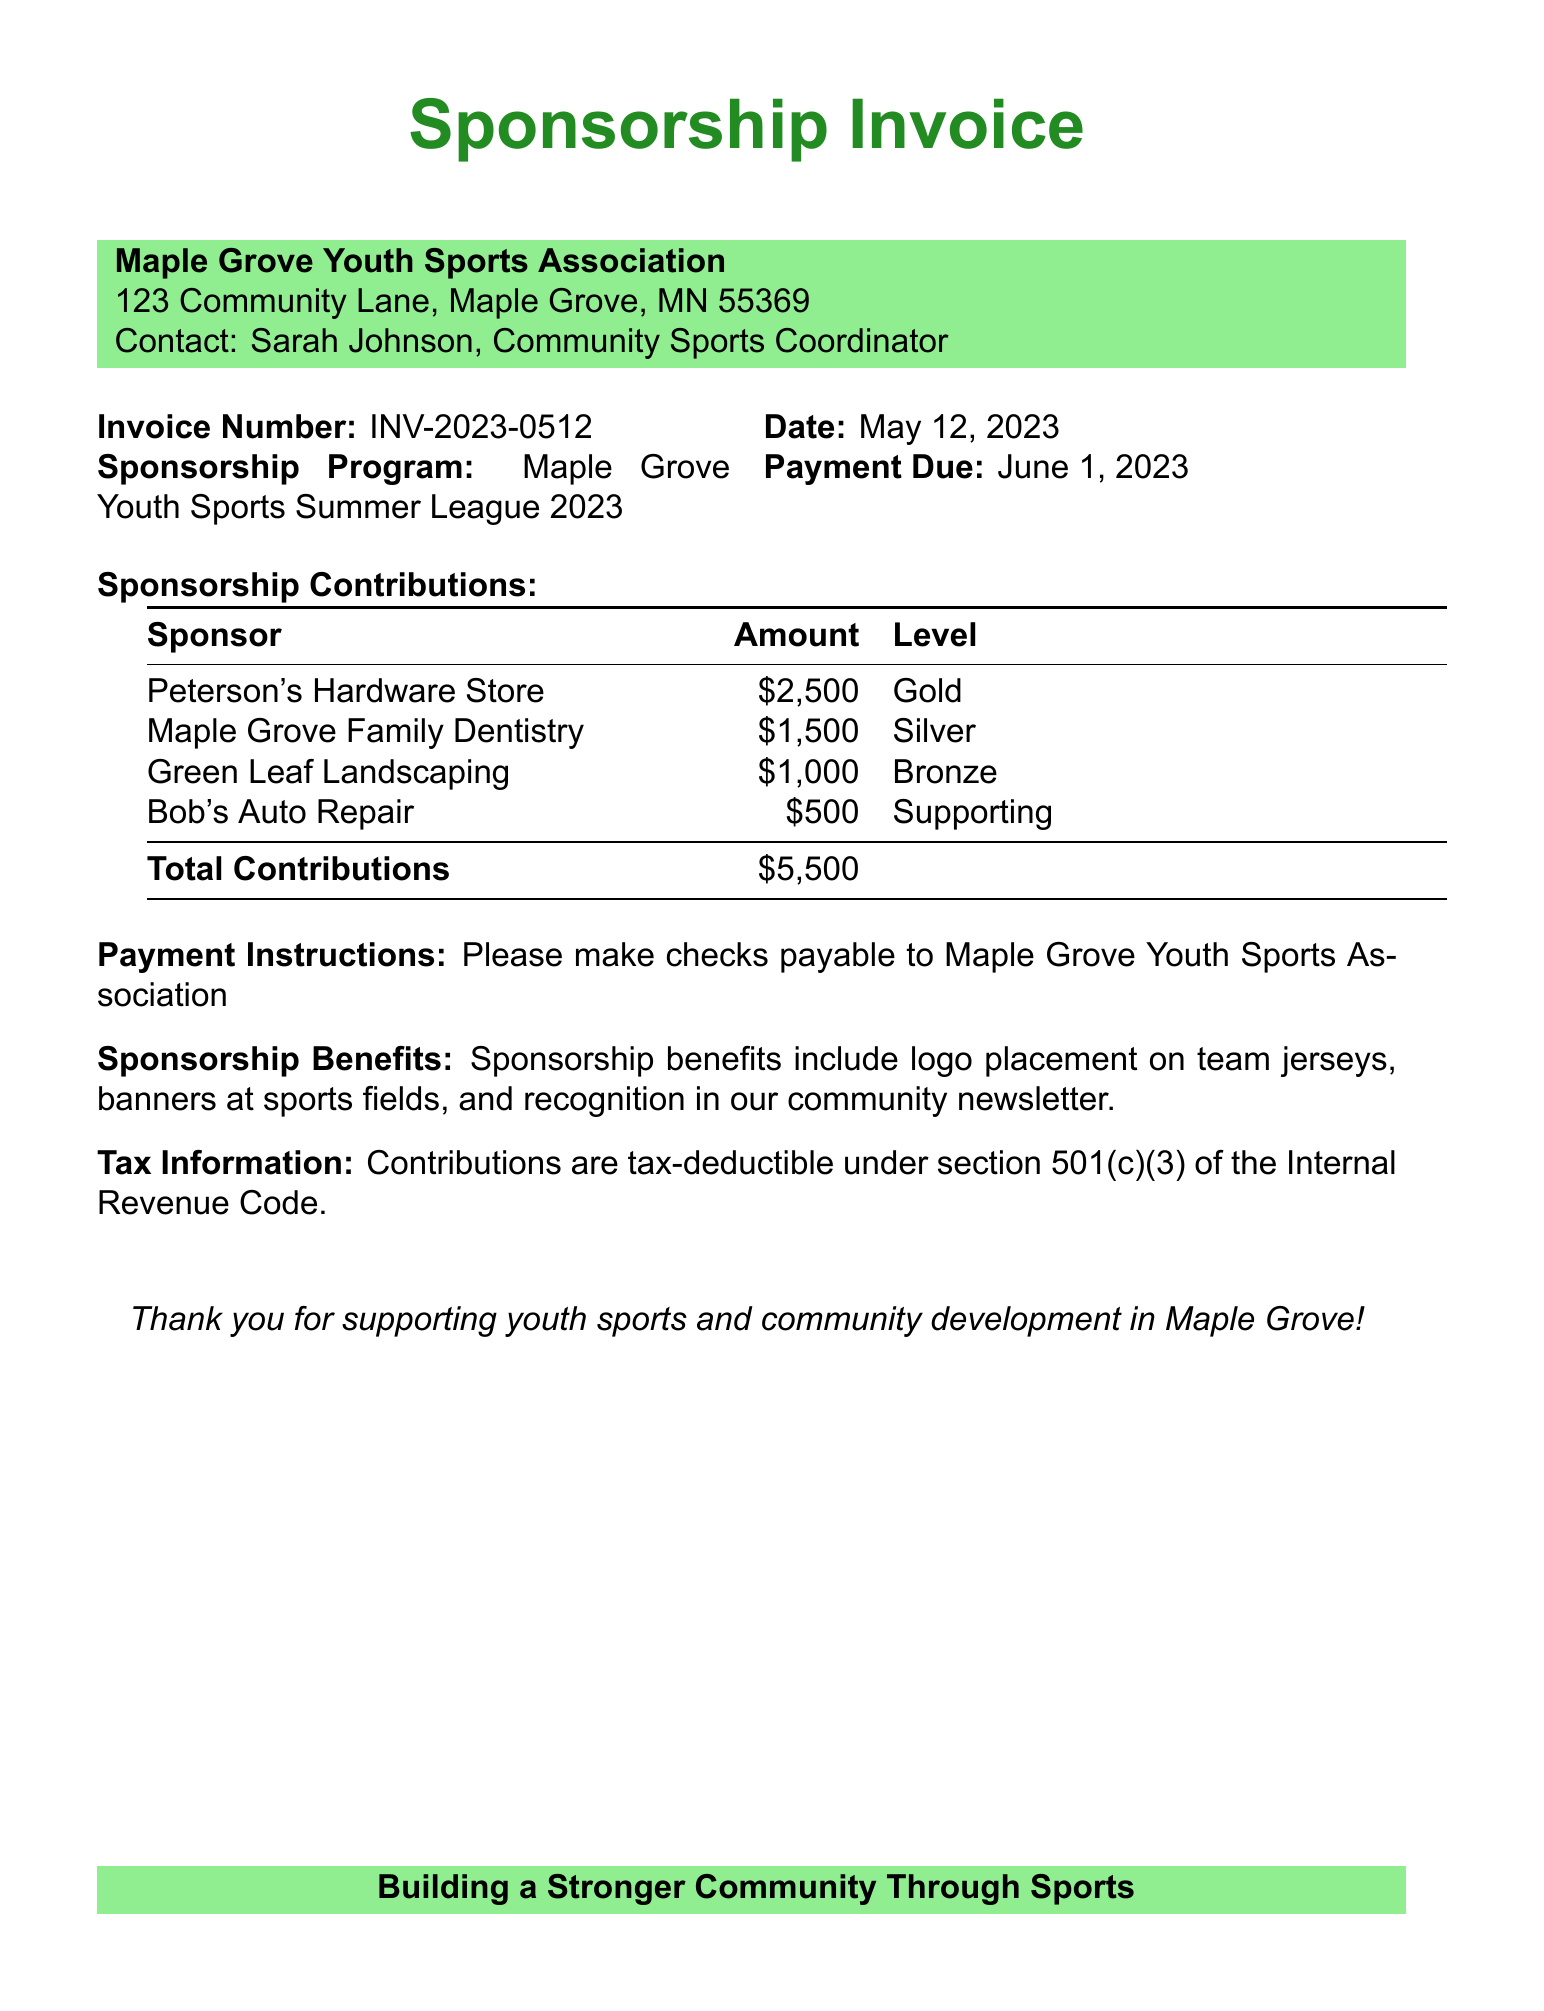what is the invoice number? The invoice number is specified in the document, which is INV-2023-0512.
Answer: INV-2023-0512 what is the payment due date? The payment due date is explicitly mentioned in the document as June 1, 2023.
Answer: June 1, 2023 how much did Peterson's Hardware Store contribute? The contribution amount from Peterson's Hardware Store is detailed in the sponsorship contributions section as $2,500.
Answer: $2,500 who is the contact person for the Maple Grove Youth Sports Association? The contact person is listed in the document, which is Sarah Johnson, Community Sports Coordinator.
Answer: Sarah Johnson what level of sponsorship did Maple Grove Family Dentistry have? The sponsorship level for Maple Grove Family Dentistry is provided in the table, which is Silver.
Answer: Silver what is the total amount of contributions? The total contributions are summed up in the document, which is $5,500.
Answer: $5,500 what are the benefits of sponsorship listed in the document? The benefits of sponsorship include various promotional aspects such as logo placement on team jerseys and recognition in a community newsletter.
Answer: logo placement on team jerseys, banners at sports fields, and recognition in our community newsletter is the contribution tax-deductible? The document specifies that contributions are tax-deductible under section 501(c)(3).
Answer: yes 